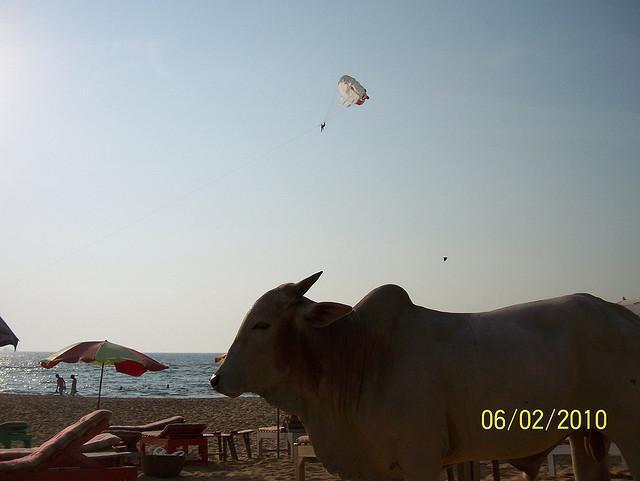How many people are close to the ocean?
Give a very brief answer. 2. How many giraffes are pictured?
Give a very brief answer. 0. 